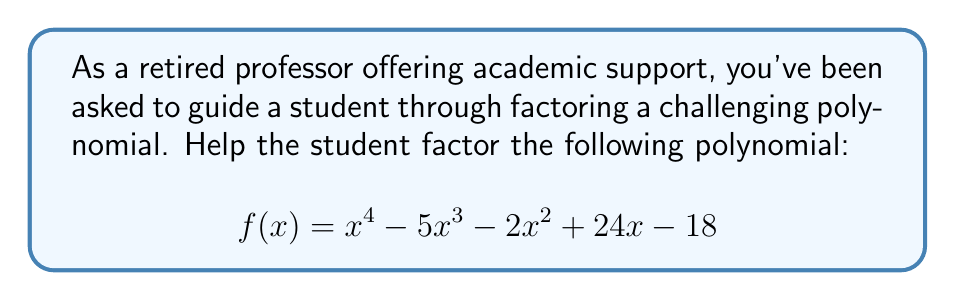Can you answer this question? Let's approach this step-by-step:

1) First, we'll check if there are any common factors. In this case, there are none.

2) Next, we'll check if this is a perfect square trinomial. It isn't, as the middle term doesn't match the pattern.

3) Let's try the rational root theorem. The possible rational roots are the factors of the constant term (±1, ±2, ±3, ±6, ±9, ±18).

4) Testing these values, we find that $f(1) = 0$. So $(x-1)$ is a factor.

5) Divide $f(x)$ by $(x-1)$ using polynomial long division:

   $$\frac{x^4 - 5x^3 - 2x^2 + 24x - 18}{x-1} = x^3 - 4x^2 - 6x + 18$$

6) Now we have: $f(x) = (x-1)(x^3 - 4x^2 - 6x + 18)$

7) Let's factor the cubic part. Testing rational roots again, we find that 3 is a root.

8) Dividing $(x^3 - 4x^2 - 6x + 18)$ by $(x-3)$:

   $$\frac{x^3 - 4x^2 - 6x + 18}{x-3} = x^2 - x - 6$$

9) The quadratic $x^2 - x - 6$ can be factored as $(x-3)(x+2)$

10) Putting it all together:

    $$f(x) = (x-1)(x-3)(x-3)(x+2)$$

11) Simplifying:

    $$f(x) = (x-1)(x-3)^2(x+2)$$
Answer: $(x-1)(x-3)^2(x+2)$ 